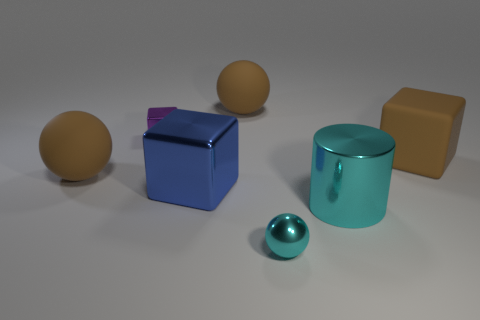Subtract all red cylinders. How many brown balls are left? 2 Subtract all metallic cubes. How many cubes are left? 1 Subtract 1 cubes. How many cubes are left? 2 Add 1 purple objects. How many objects exist? 8 Subtract all big blocks. Subtract all cyan metal cylinders. How many objects are left? 4 Add 6 cyan metal things. How many cyan metal things are left? 8 Add 5 big metallic things. How many big metallic things exist? 7 Subtract 1 purple cubes. How many objects are left? 6 Subtract all cylinders. How many objects are left? 6 